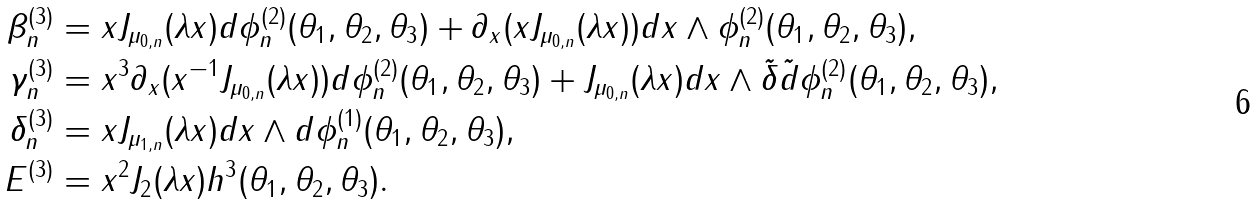Convert formula to latex. <formula><loc_0><loc_0><loc_500><loc_500>\beta ^ { ( 3 ) } _ { n } & = x J _ { \mu _ { 0 , n } } ( \lambda x ) d \phi ^ { ( 2 ) } _ { n } ( \theta _ { 1 } , \theta _ { 2 } , \theta _ { 3 } ) + \partial _ { x } ( x J _ { \mu _ { 0 , n } } ( \lambda x ) ) d x \wedge \phi ^ { ( 2 ) } _ { n } ( \theta _ { 1 } , \theta _ { 2 } , \theta _ { 3 } ) , \\ \gamma ^ { ( 3 ) } _ { n } & = x ^ { 3 } \partial _ { x } ( x ^ { - 1 } J _ { \mu _ { 0 , n } } ( \lambda x ) ) d \phi ^ { ( 2 ) } _ { n } ( \theta _ { 1 } , \theta _ { 2 } , \theta _ { 3 } ) + J _ { \mu _ { 0 , n } } ( \lambda x ) d x \wedge \tilde { \delta } \tilde { d } \phi ^ { ( 2 ) } _ { n } ( \theta _ { 1 } , \theta _ { 2 } , \theta _ { 3 } ) , \\ \delta ^ { ( 3 ) } _ { n } & = x J _ { \mu _ { 1 , n } } ( \lambda x ) d x \wedge d \phi ^ { ( 1 ) } _ { n } ( \theta _ { 1 } , \theta _ { 2 } , \theta _ { 3 } ) , \\ E ^ { ( 3 ) } & = x ^ { 2 } J _ { 2 } ( \lambda x ) h ^ { 3 } ( \theta _ { 1 } , \theta _ { 2 } , \theta _ { 3 } ) .</formula> 